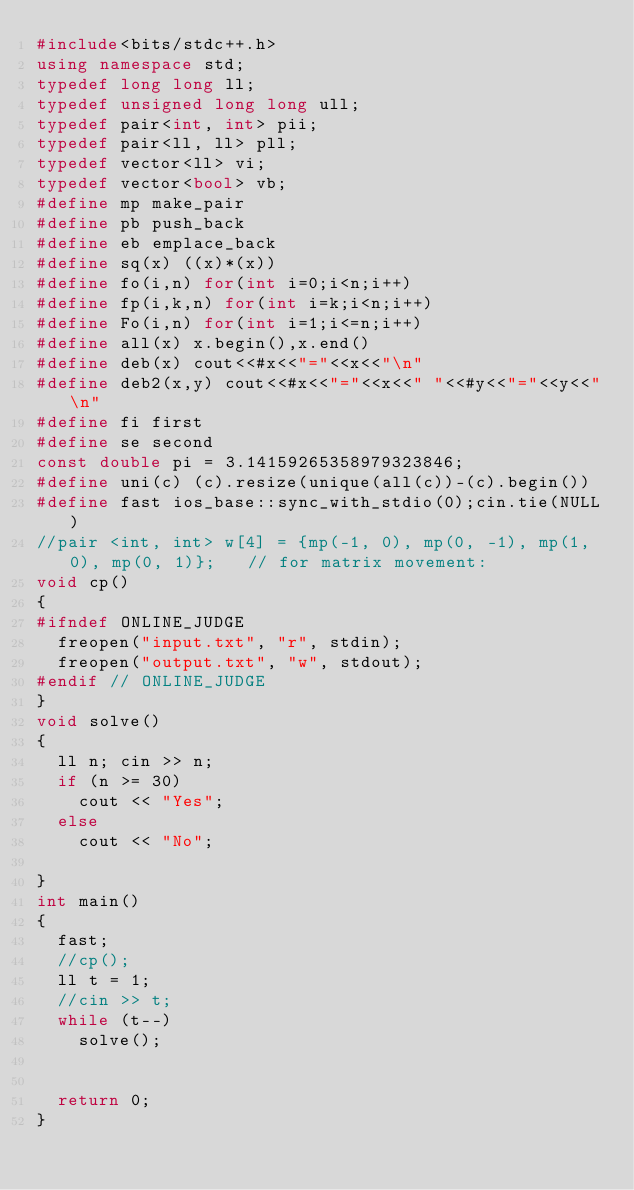<code> <loc_0><loc_0><loc_500><loc_500><_C++_>#include<bits/stdc++.h>
using namespace std;
typedef long long ll;
typedef unsigned long long ull;
typedef pair<int, int> pii;
typedef pair<ll, ll> pll;
typedef vector<ll> vi;
typedef vector<bool> vb;
#define mp make_pair
#define pb push_back
#define eb emplace_back
#define sq(x) ((x)*(x))
#define fo(i,n) for(int i=0;i<n;i++)
#define fp(i,k,n) for(int i=k;i<n;i++)
#define Fo(i,n) for(int i=1;i<=n;i++)
#define all(x) x.begin(),x.end()
#define deb(x) cout<<#x<<"="<<x<<"\n"
#define deb2(x,y) cout<<#x<<"="<<x<<" "<<#y<<"="<<y<<"\n"
#define fi first
#define se second
const double pi = 3.14159265358979323846;
#define uni(c) (c).resize(unique(all(c))-(c).begin())
#define fast ios_base::sync_with_stdio(0);cin.tie(NULL)
//pair <int, int> w[4] = {mp(-1, 0), mp(0, -1), mp(1, 0), mp(0, 1)};   // for matrix movement:
void cp()
{
#ifndef ONLINE_JUDGE
	freopen("input.txt", "r", stdin);
	freopen("output.txt", "w", stdout);
#endif // ONLINE_JUDGE
}
void solve()
{
	ll n; cin >> n;
	if (n >= 30)
		cout << "Yes";
	else
		cout << "No";

}
int main()
{
	fast;
	//cp();
	ll t = 1;
	//cin >> t;
	while (t--)
		solve();


	return 0;
}</code> 